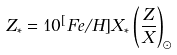<formula> <loc_0><loc_0><loc_500><loc_500>Z _ { * } = 1 0 ^ { [ } F e / H ] X _ { * } \left ( \frac { Z } { X } \right ) _ { \odot }</formula> 